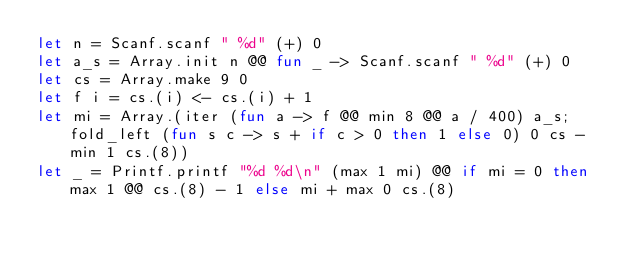Convert code to text. <code><loc_0><loc_0><loc_500><loc_500><_OCaml_>let n = Scanf.scanf " %d" (+) 0
let a_s = Array.init n @@ fun _ -> Scanf.scanf " %d" (+) 0
let cs = Array.make 9 0
let f i = cs.(i) <- cs.(i) + 1
let mi = Array.(iter (fun a -> f @@ min 8 @@ a / 400) a_s; fold_left (fun s c -> s + if c > 0 then 1 else 0) 0 cs - min 1 cs.(8))
let _ = Printf.printf "%d %d\n" (max 1 mi) @@ if mi = 0 then max 1 @@ cs.(8) - 1 else mi + max 0 cs.(8)</code> 